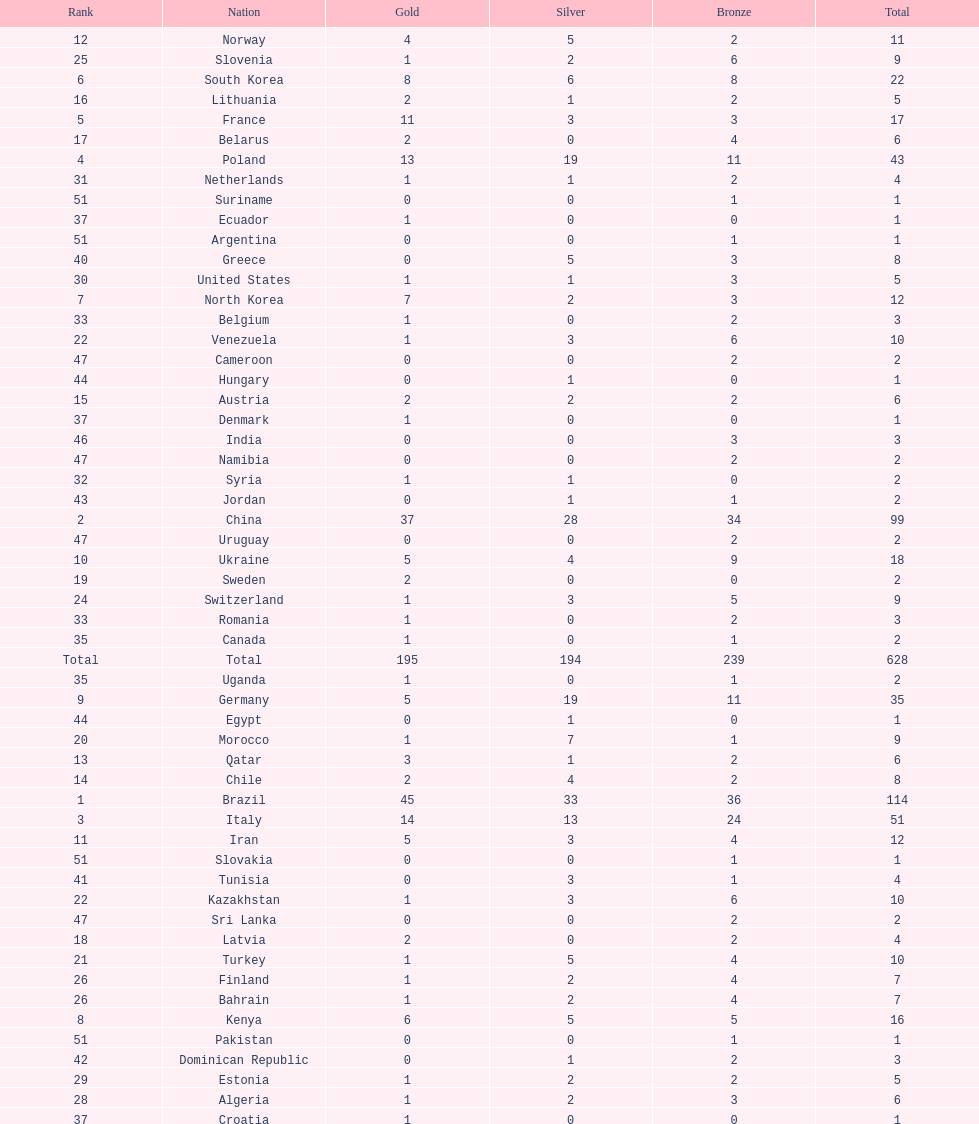Who only won 13 silver medals? Italy. 